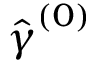Convert formula to latex. <formula><loc_0><loc_0><loc_500><loc_500>\hat { \gamma } ^ { ( 0 ) }</formula> 